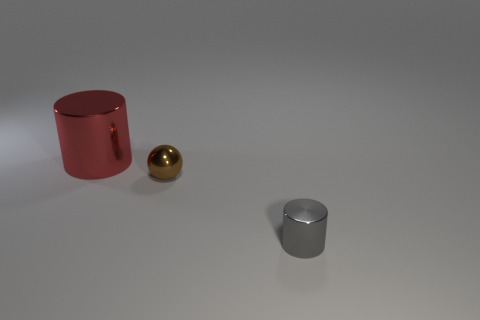Add 3 small shiny cylinders. How many objects exist? 6 Subtract all balls. How many objects are left? 2 Add 1 tiny gray shiny things. How many tiny gray shiny things are left? 2 Add 1 tiny green blocks. How many tiny green blocks exist? 1 Subtract 0 green cubes. How many objects are left? 3 Subtract all red cylinders. Subtract all red objects. How many objects are left? 1 